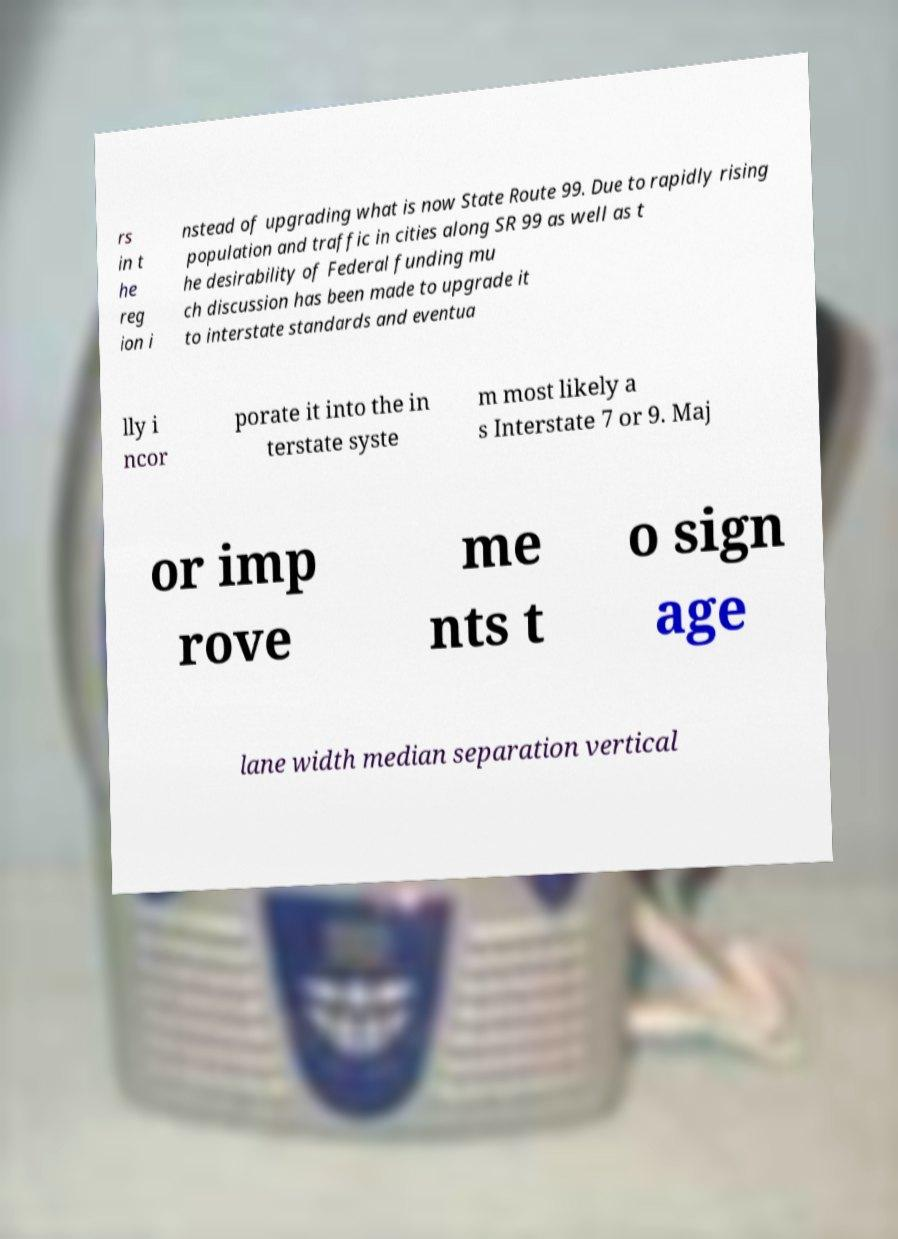For documentation purposes, I need the text within this image transcribed. Could you provide that? rs in t he reg ion i nstead of upgrading what is now State Route 99. Due to rapidly rising population and traffic in cities along SR 99 as well as t he desirability of Federal funding mu ch discussion has been made to upgrade it to interstate standards and eventua lly i ncor porate it into the in terstate syste m most likely a s Interstate 7 or 9. Maj or imp rove me nts t o sign age lane width median separation vertical 